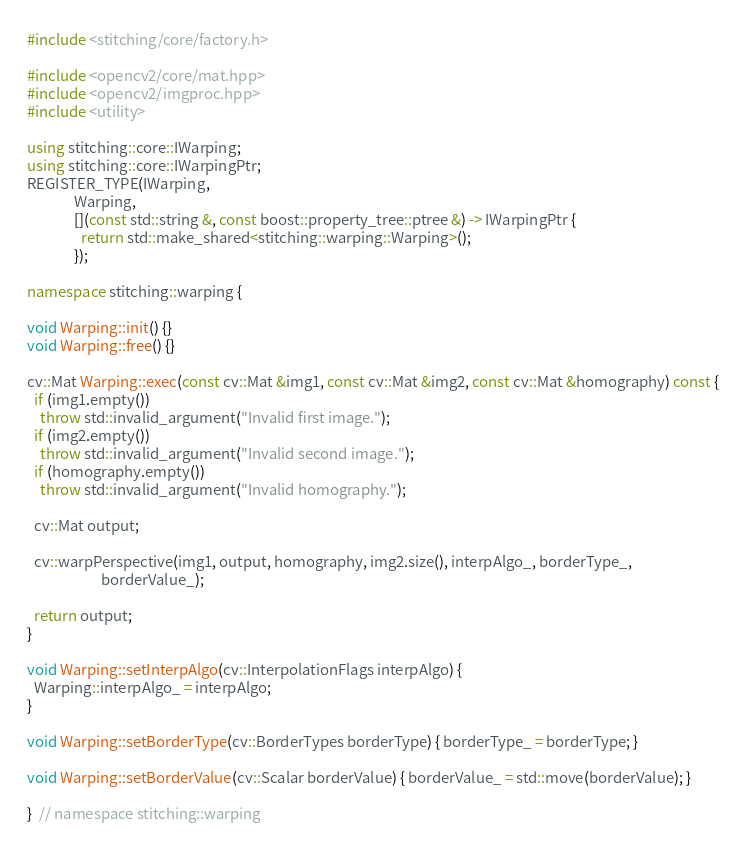Convert code to text. <code><loc_0><loc_0><loc_500><loc_500><_C++_>
#include <stitching/core/factory.h>

#include <opencv2/core/mat.hpp>
#include <opencv2/imgproc.hpp>
#include <utility>

using stitching::core::IWarping;
using stitching::core::IWarpingPtr;
REGISTER_TYPE(IWarping,
              Warping,
              [](const std::string &, const boost::property_tree::ptree &) -> IWarpingPtr {
                return std::make_shared<stitching::warping::Warping>();
              });

namespace stitching::warping {

void Warping::init() {}
void Warping::free() {}

cv::Mat Warping::exec(const cv::Mat &img1, const cv::Mat &img2, const cv::Mat &homography) const {
  if (img1.empty())
    throw std::invalid_argument("Invalid first image.");
  if (img2.empty())
    throw std::invalid_argument("Invalid second image.");
  if (homography.empty())
    throw std::invalid_argument("Invalid homography.");

  cv::Mat output;

  cv::warpPerspective(img1, output, homography, img2.size(), interpAlgo_, borderType_,
                      borderValue_);

  return output;
}

void Warping::setInterpAlgo(cv::InterpolationFlags interpAlgo) {
  Warping::interpAlgo_ = interpAlgo;
}

void Warping::setBorderType(cv::BorderTypes borderType) { borderType_ = borderType; }

void Warping::setBorderValue(cv::Scalar borderValue) { borderValue_ = std::move(borderValue); }

}  // namespace stitching::warping
</code> 